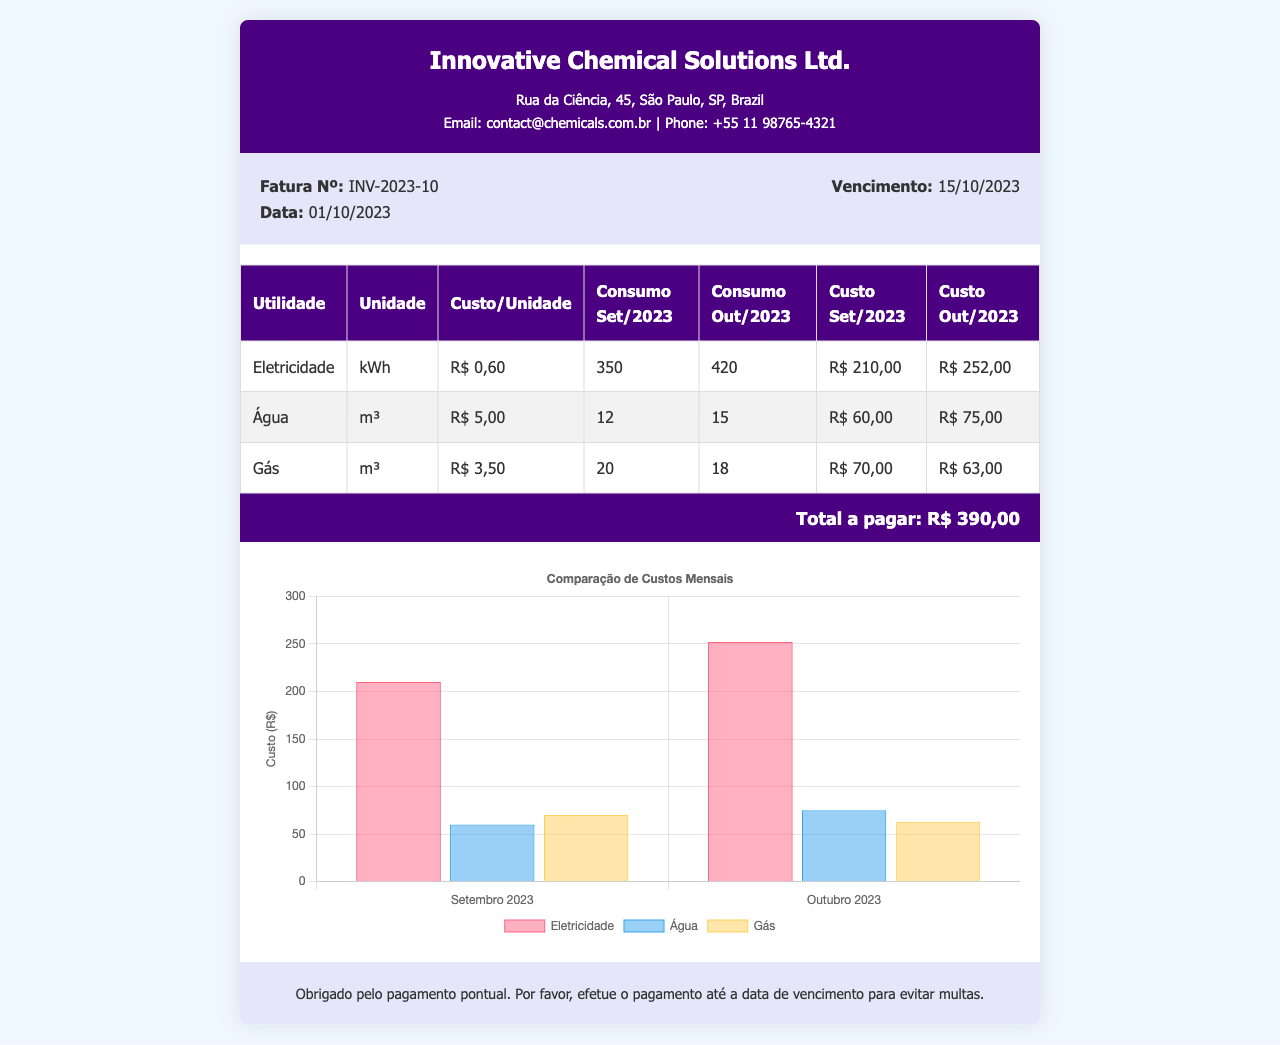What is the invoice number? The invoice number is clearly stated in the document as "Fatura Nº:" followed by the unique invoice number.
Answer: INV-2023-10 What is the due date for this invoice? The due date is indicated under the invoice details section labeled as "Vencimento:".
Answer: 15/10/2023 What was the cost for electricity in October 2023? The cost for electricity for October 2023 is found in the consumption table under the corresponding column.
Answer: R$ 252,00 How much water was consumed in September 2023? The water consumption for September 2023 is recorded in the consumption table.
Answer: 12 m³ Which utility had the highest cost increase from September to October 2023? This requires comparing costs of utilities from both months, notable from the consumption table.
Answer: Eletricidade What is the total amount to be paid? The total to be paid is indicated clearly at the bottom of the document under "Total a pagar:".
Answer: R$ 390,00 How many cubic meters of gas were consumed in October 2023? The gas consumption for October 2023 is reported in the consumption table.
Answer: 18 m³ What is the cost of water per unit? The cost per unit for water is specified in the consumption table.
Answer: R$ 5,00 What type of chart is included in the invoice? The type of chart can be identified from the context provided in the document regarding its visualization.
Answer: Bar chart 